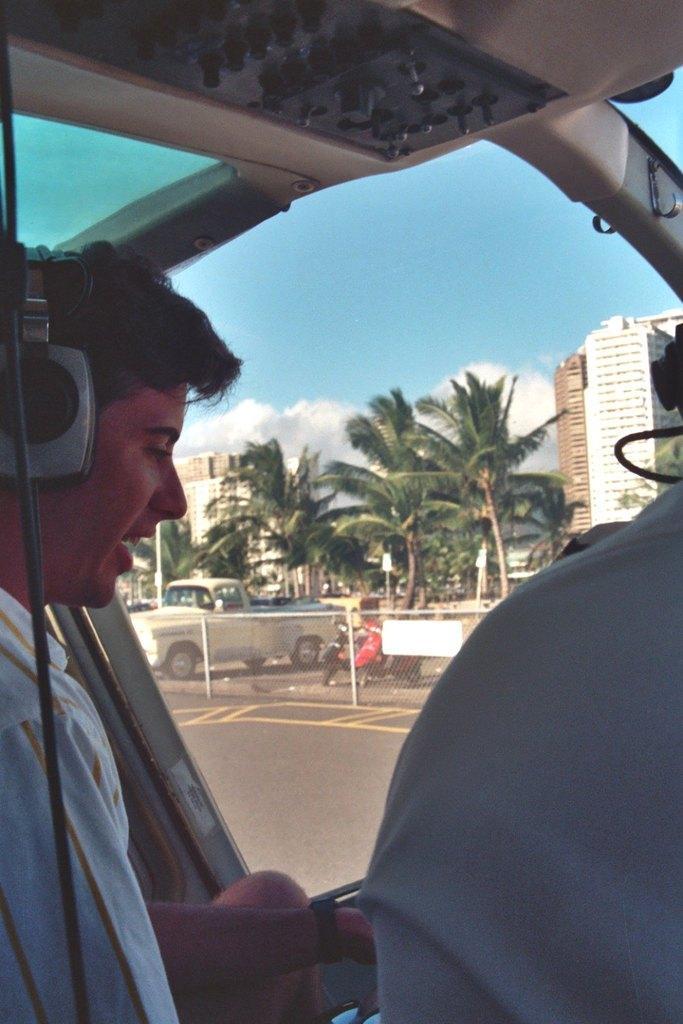Describe this image in one or two sentences. In this image there are two pilots sitting in the helicopter. They are keeping headphones. In front of them there is a glass through which we can see that there are buildings and trees beside them. On the road there is a car. 